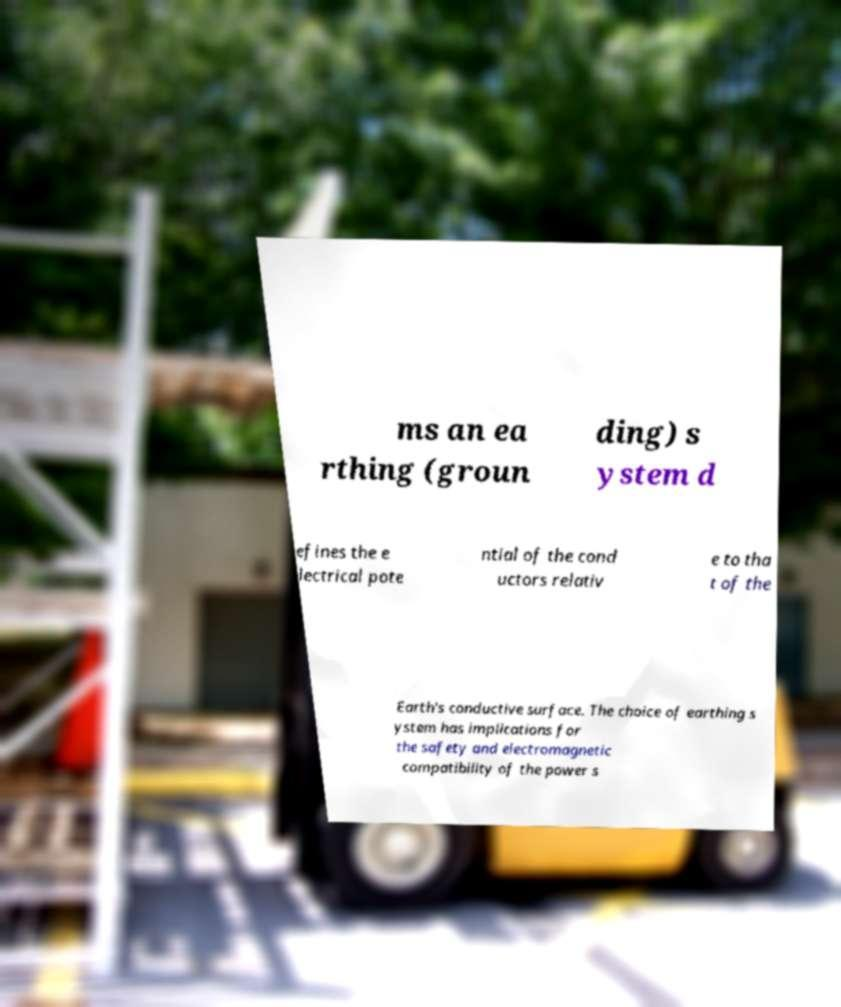Please identify and transcribe the text found in this image. ms an ea rthing (groun ding) s ystem d efines the e lectrical pote ntial of the cond uctors relativ e to tha t of the Earth's conductive surface. The choice of earthing s ystem has implications for the safety and electromagnetic compatibility of the power s 